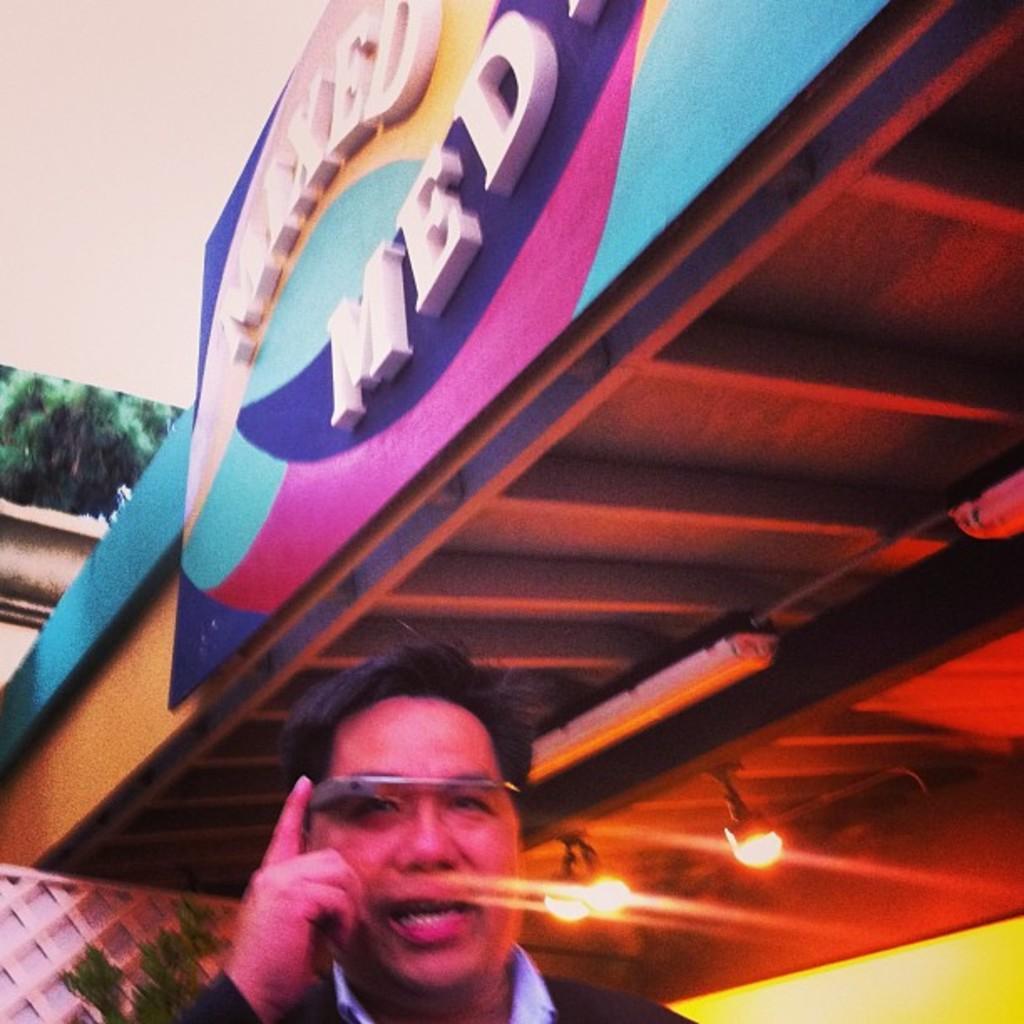Could you give a brief overview of what you see in this image? In this image, we can see a hoarding, roof with lights. At the bottom, we can see a man. Background we can see plant, grill and wall. 